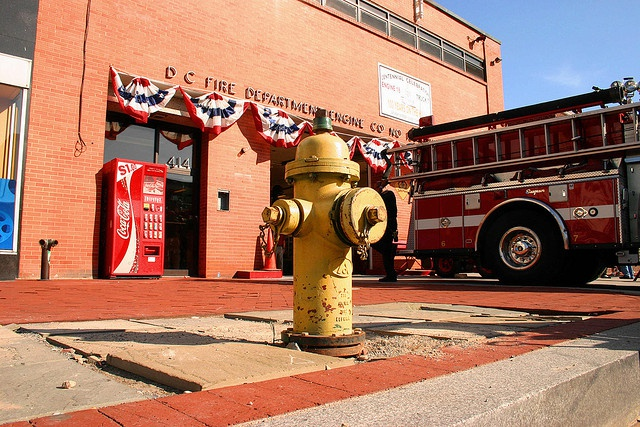Describe the objects in this image and their specific colors. I can see truck in gray, black, and maroon tones, fire hydrant in gray, olive, khaki, maroon, and black tones, and people in gray, black, maroon, tan, and brown tones in this image. 